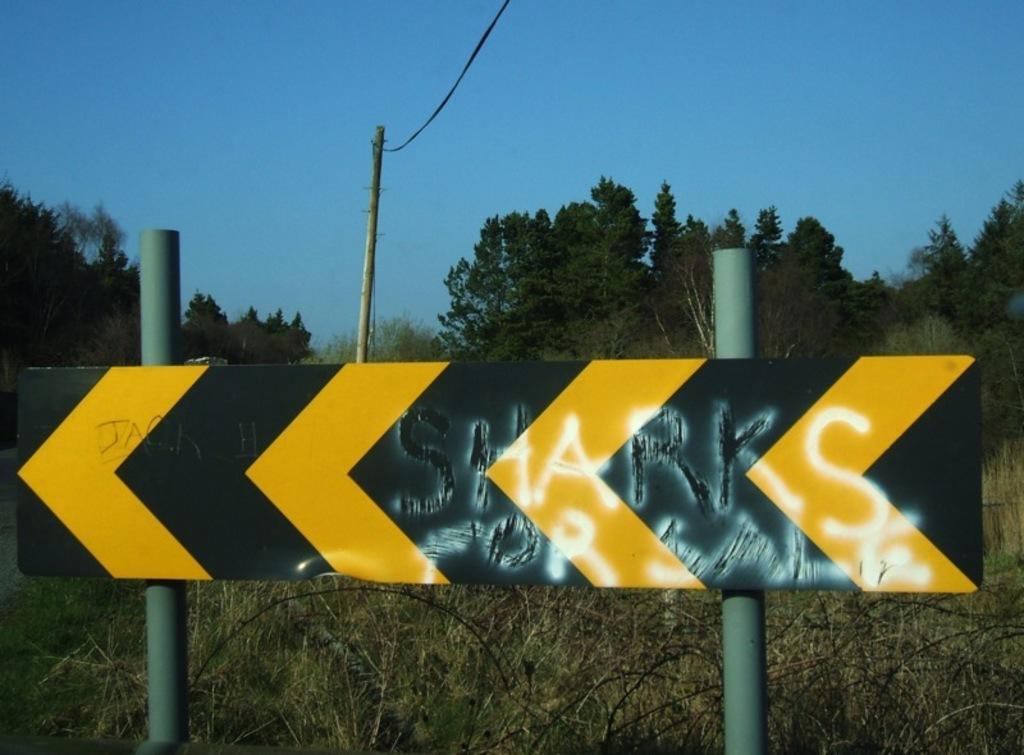What is featured on the board in the image? There is text on a board in the image. What can be seen in the background of the image? There are trees in the background of the image. What is visible at the top of the image? The sky is visible at the top of the image. Can you tell me how many apples are on the minister's desk in the image? There is no minister or desk present in the image, and therefore no apples can be observed. 